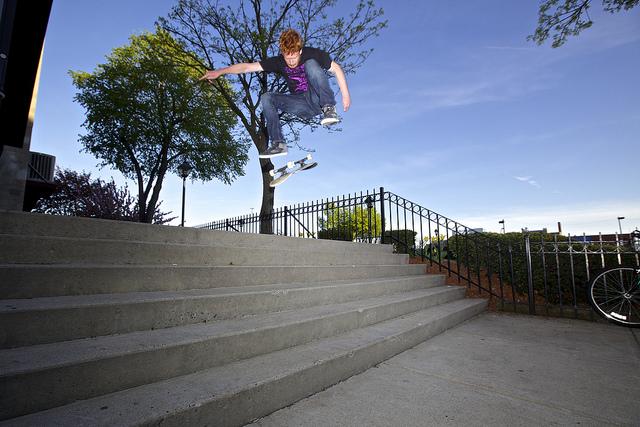Can you see a bike wheel?
Be succinct. Yes. Is this a safe activity?
Short answer required. No. Is the skateboard upside down?
Short answer required. Yes. 